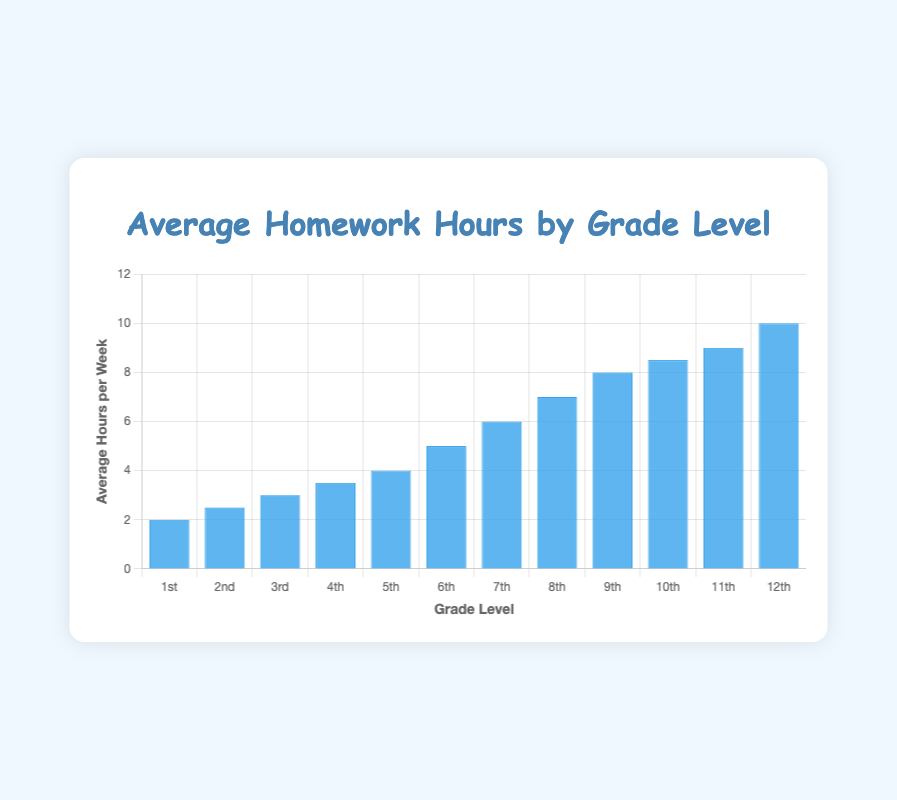What's the highest average number of homework hours per week by grade level? The highest bar in the chart represents the grade with the highest average hours. The 12th grade has the highest bar indicating 10 hours per week.
Answer: 12th Grade Which grades have an average of 5 or more hours of homework per week? We look at bars that are at least as tall as the 5-hour mark on the y-axis. Grades 6th through 12th meet this requirement.
Answer: 6th through 12th Grades How much more average homework hours are there in 10th grade compared to 1st grade? The bar for 10th grade shows 8.5 hours and the bar for 1st grade shows 2 hours. The difference is 8.5 - 2.
Answer: 6.5 hours What's the average number of homework hours per week for grades 1 through 4? Add the average hours for grades 1 to 4 and then divide by the number of grades: (2 + 2.5 + 3 + 3.5) / 4.
Answer: 2.75 hours What's the difference in average homework hours between 11th and 9th grade? Subtract the average hours for 9th grade from those of 11th grade: 9 - 8.
Answer: 1 hour How does the average homework time change from 6th grade to 7th grade? Compare the bar heights for 6th (5 hours) and 7th grade (6 hours). The increase from 6th to 7th grade is 6 - 5.
Answer: Increases by 1 hour Which grades have an average homework time that is less than 4 hours per week? Identify bars that are below the 4-hour mark on the y-axis. Grades from 1st to 4th meet this criterion.
Answer: 1st to 4th Grades What is the total average homework hours per week for the first 6 grades combined? Sum the average hours for grades 1 through 6: 2 + 2.5 + 3 + 3.5 + 4 + 5.
Answer: 20 hours Compare the average homework hours between 5th and 12th grade. How much greater is the average homework for 12th grade? The average hours for 5th grade are 4 and for 12th grade are 10. The difference is 10 - 4.
Answer: 6 hours What's the ratio of average homework hours between the 8th and 4th grades? Divide the average hours for 8th grade by that of 4th grade: 7 / 3.5.
Answer: 2:1 